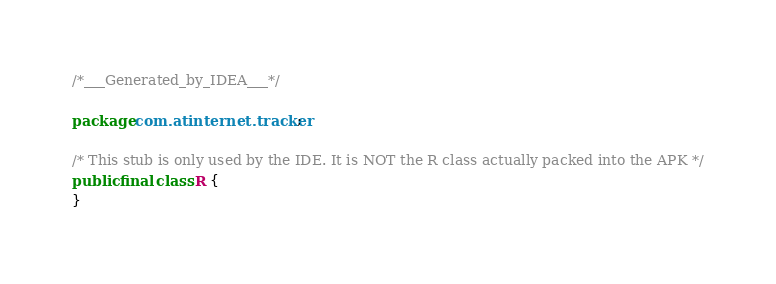Convert code to text. <code><loc_0><loc_0><loc_500><loc_500><_Java_>/*___Generated_by_IDEA___*/

package com.atinternet.tracker;

/* This stub is only used by the IDE. It is NOT the R class actually packed into the APK */
public final class R {
}</code> 